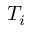<formula> <loc_0><loc_0><loc_500><loc_500>T _ { i }</formula> 